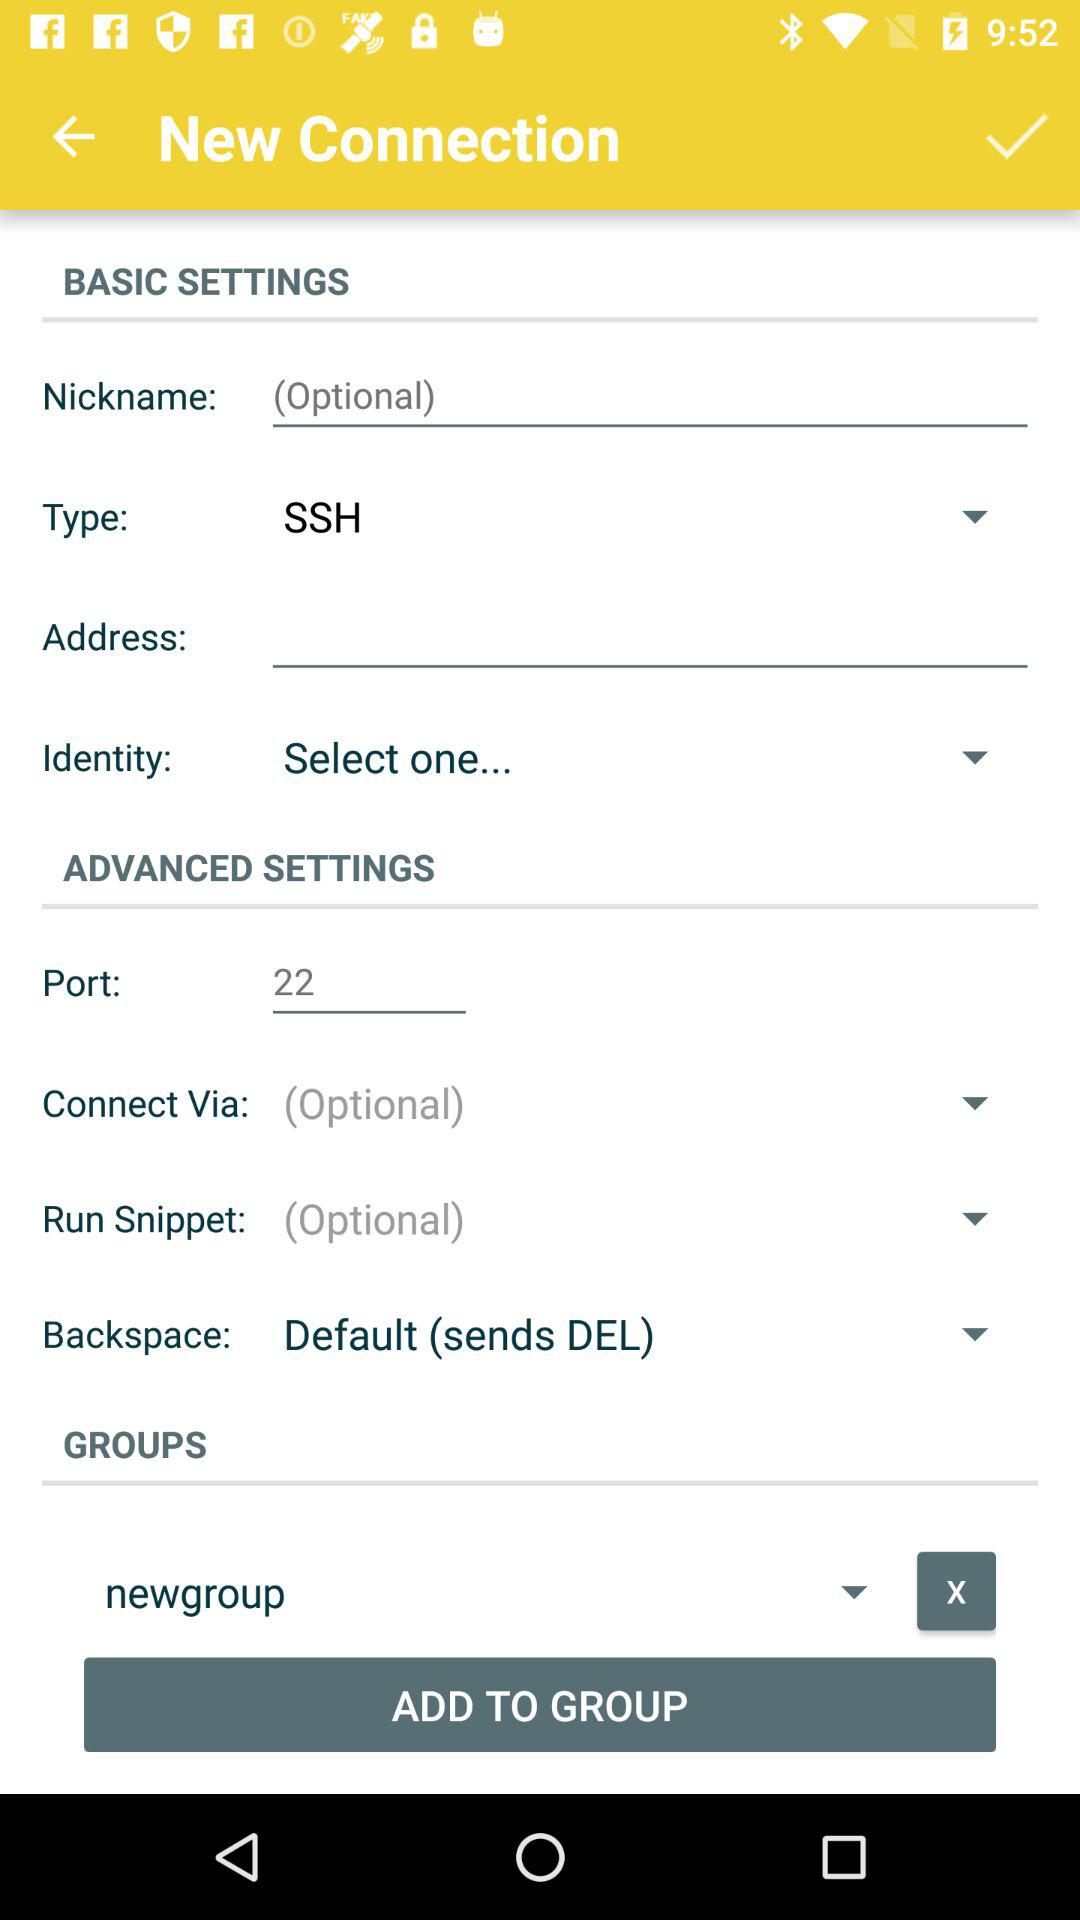What is selected in type? In type, "SSH" is selected. 